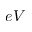<formula> <loc_0><loc_0><loc_500><loc_500>e V</formula> 